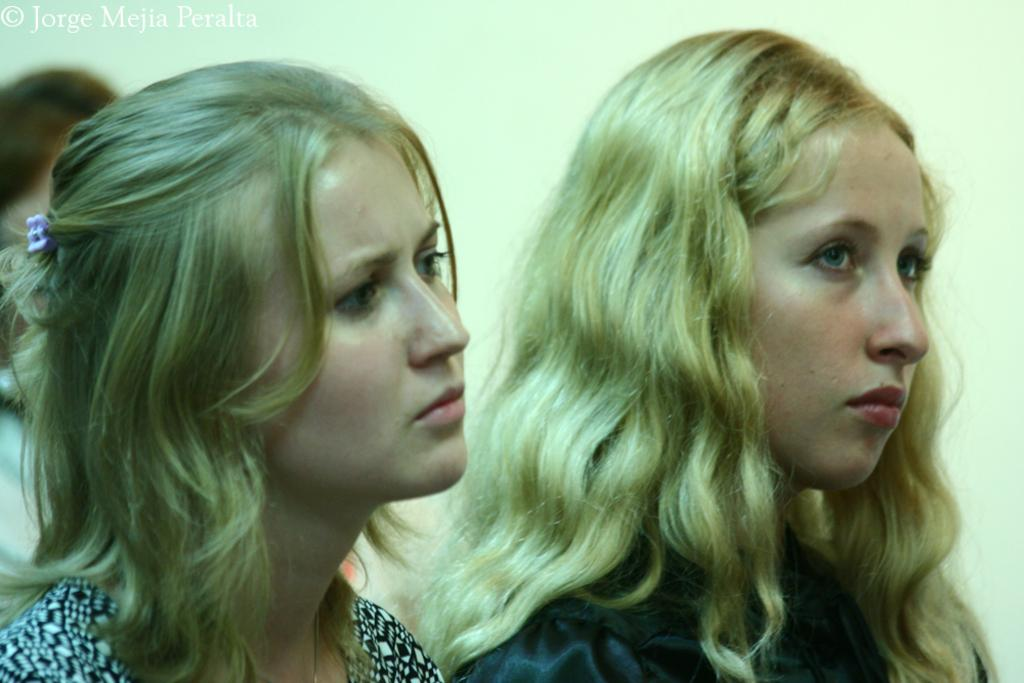What can be observed about the clothing of the people in the image? There are people with different color dresses in the image. What can be seen in the background of the image? There is a wall visible in the background of the image. Is there any additional information or marking on the image? Yes, there is a watermark in the image. What shapes can be seen in the image, specifically related to the people's dresses? There is no mention of specific shapes in the image, and the focus is on the colors of the dresses. Are there any planes visible in the image? No, there are no planes present in the image. 